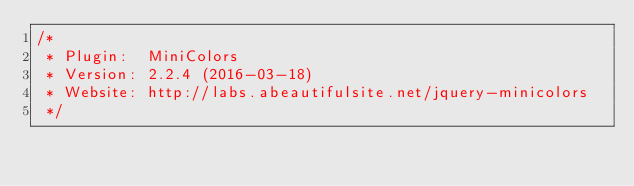<code> <loc_0><loc_0><loc_500><loc_500><_JavaScript_>/*
 * Plugin:  MiniColors
 * Version: 2.2.4 (2016-03-18)
 * Website: http://labs.abeautifulsite.net/jquery-minicolors
 */</code> 